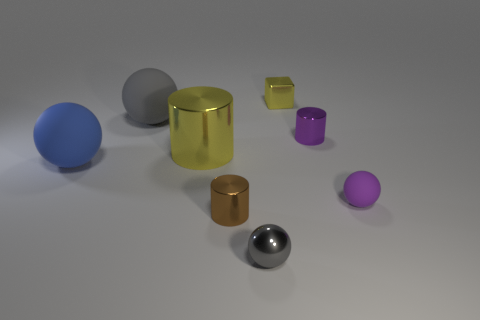Are there more yellow metal cylinders to the right of the tiny rubber object than yellow shiny things that are right of the metallic ball?
Provide a short and direct response. No. The purple metal cylinder is what size?
Provide a succinct answer. Small. Is there a big metal object of the same shape as the large gray matte object?
Give a very brief answer. No. Does the big metallic object have the same shape as the rubber thing that is right of the metal block?
Keep it short and to the point. No. How big is the cylinder that is both to the right of the big metal object and behind the blue ball?
Your answer should be compact. Small. What number of tiny purple spheres are there?
Give a very brief answer. 1. There is a yellow object that is the same size as the blue rubber sphere; what is it made of?
Ensure brevity in your answer.  Metal. Is there a purple shiny thing that has the same size as the gray metallic sphere?
Offer a very short reply. Yes. Is the color of the large rubber ball in front of the small purple metal thing the same as the cylinder in front of the blue matte thing?
Your answer should be compact. No. What number of metallic things are brown cylinders or small green things?
Provide a short and direct response. 1. 